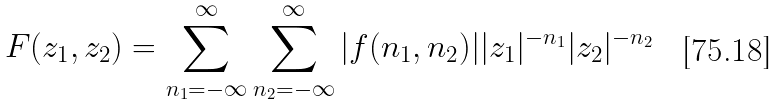<formula> <loc_0><loc_0><loc_500><loc_500>F ( z _ { 1 } , z _ { 2 } ) = \sum _ { n _ { 1 } = - \infty } ^ { \infty } \sum _ { n _ { 2 } = - \infty } ^ { \infty } | f ( n _ { 1 } , n _ { 2 } ) | | z _ { 1 } | ^ { - n _ { 1 } } | z _ { 2 } | ^ { - n _ { 2 } }</formula> 